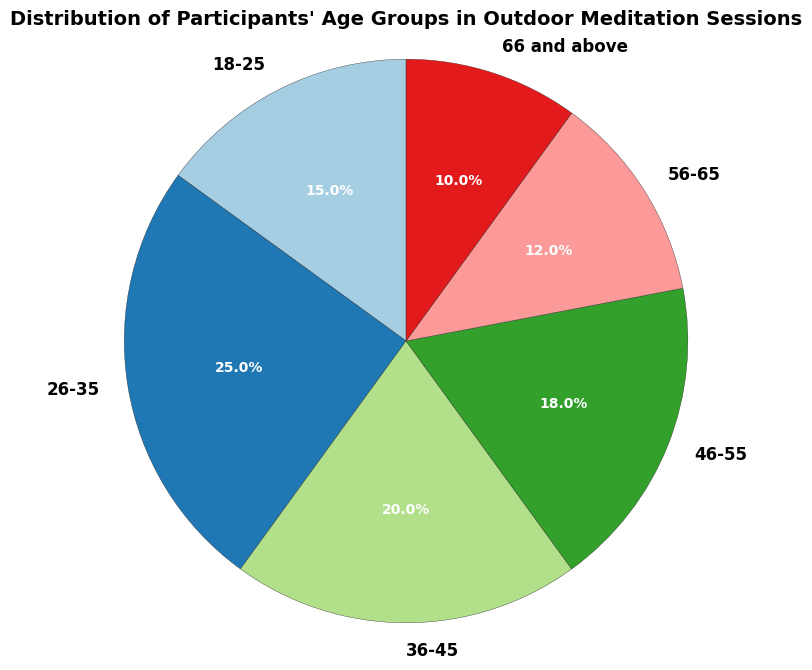What's the largest age group in the pie chart? The largest age group is the one taking up the most space in the chart. By looking at the chart, the 26-35 age group occupies the largest segment.
Answer: 26-35 What's the combined percentage of participants aged 46-55 and 56-65? Add the percentages of the 46-55 age group (18%) and the 56-65 age group (12%). 18% + 12% = 30%.
Answer: 30% Which age groups, when combined, make up less than one-third of all participants? Calculate the total percentage for age groups 66 and above and 18-25. 10% + 15% = 25%, which is less than 33.3%. So, they make up less than one-third of the total.
Answer: 18-25, 66 and above Is the percentage of participants aged 36-45 greater than the percentage of participants aged 66 and above? Compare the percentages of the groups. The 36-45 age group is 20%, while the 66 and above age group is 10%. Since 20% is greater than 10%, the answer is yes.
Answer: Yes What’s the total percentage of participants under 36 years old? Sum the percentages for age groups 18-25 and 26-35. 15% + 25% = 40%.
Answer: 40% In terms of participant count, which two consecutive age groups have the closest percentages? By comparing all pairs of consecutive age groups, the 36-45 (20%) and 46-55 (18%) age groups have the smallest difference of 2%.
Answer: 36-45 and 46-55 What's the color of the largest age group wedge in the chart? The largest age group wedge corresponds to 26-35, which is represented by the first color in the palette used. If the palette is paired, it typically starts with a light color. Identify the color directly from the chart.
Answer: [Color identified from chart] How much larger is the percentage of the 26-35 age group compared to the 66 and above age group? Subtract the percentage of the 66 and above group (10%) from the 26-35 group (25%). 25% - 10% = 15%.
Answer: 15% Is the sum of percentages of participants aged 36-45 and 56-65 greater than 45%? Add the percentages of the 36-45 (20%) and 56-65 (12%) age groups. 20% + 12% = 32%, which is less than 45%.
Answer: No What’s the smallest age group in the pie chart and its corresponding percentage? The smallest age group can be identified as taking up the least space in the pie chart. The 66 and above age group has the smallest percentage at 10%.
Answer: 66 and above, 10% 